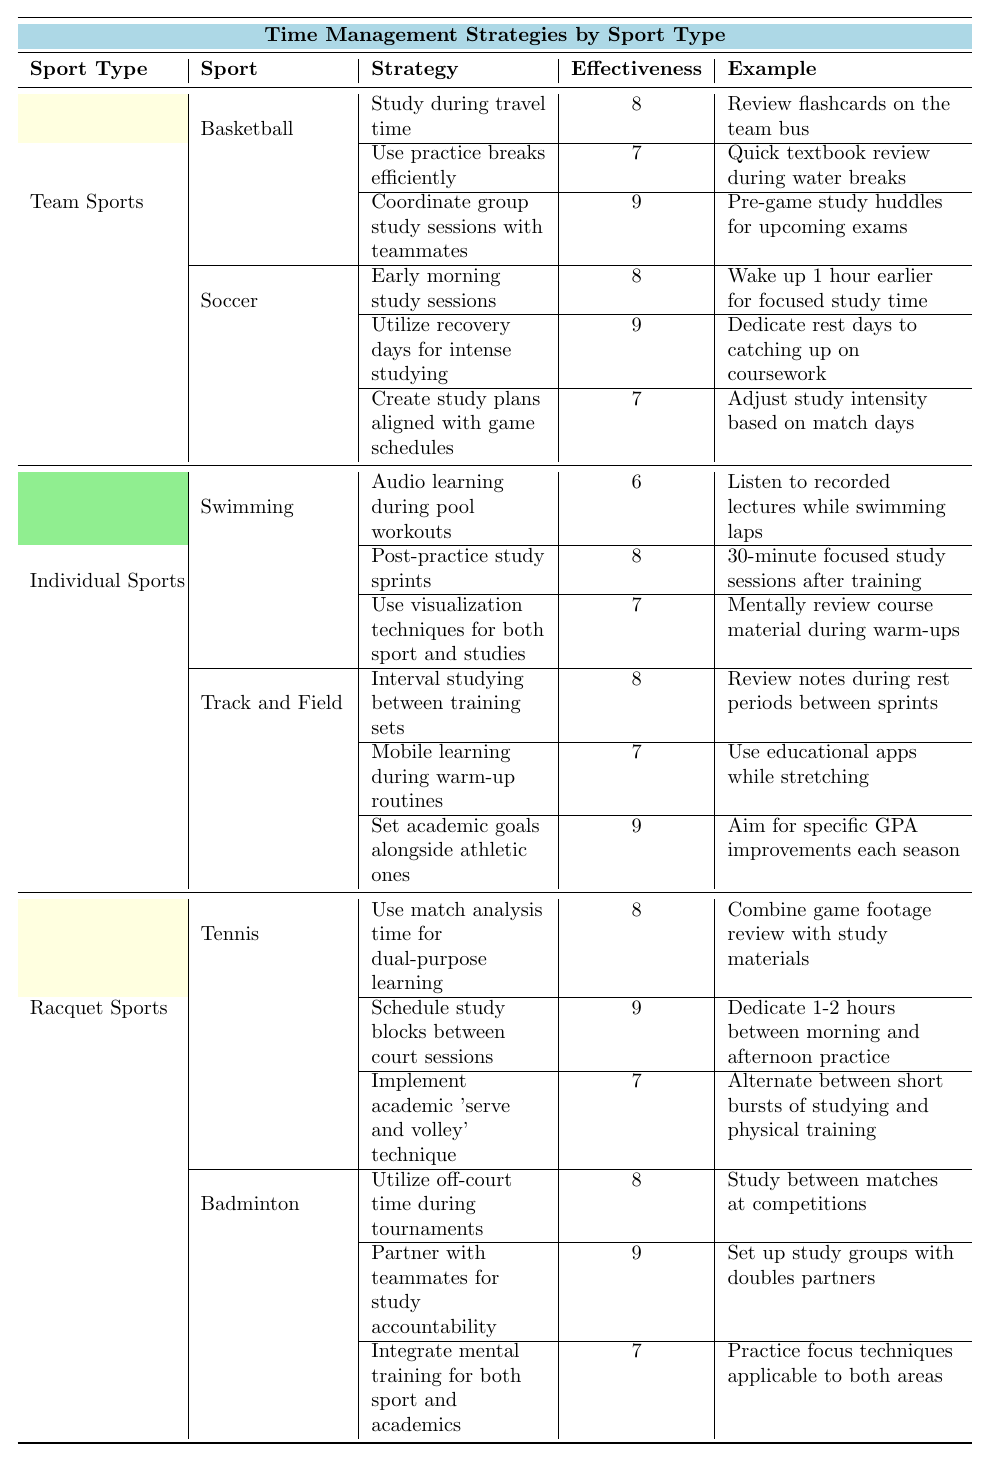What is the effectiveness score of the strategy "Post-practice study sprints" in Swimming? The strategy "Post-practice study sprints" in Swimming has an effectiveness score of 8, as indicated in the table.
Answer: 8 Which sport has the highest effectiveness score for study strategies? The sport of Tennis has the highest effectiveness score of 9 from the strategy "Schedule study blocks between court sessions."
Answer: Tennis Is "Early morning study sessions" considered an effective strategy? Yes, "Early morning study sessions" has an effectiveness score of 8, making it a reasonably effective strategy.
Answer: Yes What are the three strategies listed under Soccer? The three strategies listed under Soccer are: "Early morning study sessions," "Utilize recovery days for intense studying," and "Create study plans aligned with game schedules."
Answer: Early morning study sessions, Utilize recovery days for intense studying, Create study plans aligned with game schedules Which strategy in Tennis has the lowest effectiveness score? The strategy in Tennis with the lowest effectiveness score is "Implement academic 'serve and volley' technique," which has a score of 7.
Answer: Implement academic 'serve and volley' technique If you average the effectiveness scores of the strategies under Track and Field, what do you get? The effectiveness scores for Track and Field are 8, 7, and 9. Summing these gives 8 + 7 + 9 = 24, and dividing by 3 gives an average of 24 / 3 = 8.
Answer: 8 Are there more study strategies listed under Individual Sports or Team Sports? There are a total of 6 strategies under Individual Sports and 6 strategies under Team Sports; they are equal.
Answer: Equal Which sport strategy combines studying with recovery days? The strategy that combines studying with recovery days is "Utilize recovery days for intense studying" in Soccer, which has an effectiveness score of 9.
Answer: Utilize recovery days for intense studying How many strategies in Racquet Sports have an effectiveness score of 9? There are two strategies in Racquet Sports with an effectiveness score of 9: "Schedule study blocks between court sessions" in Tennis and "Partner with teammates for study accountability" in Badminton.
Answer: 2 Which sport is likely to benefit from "Audio learning during pool workouts"? The sport likely to benefit from "Audio learning during pool workouts" is Swimming, as it specifically describes a strategy for that sport.
Answer: Swimming 